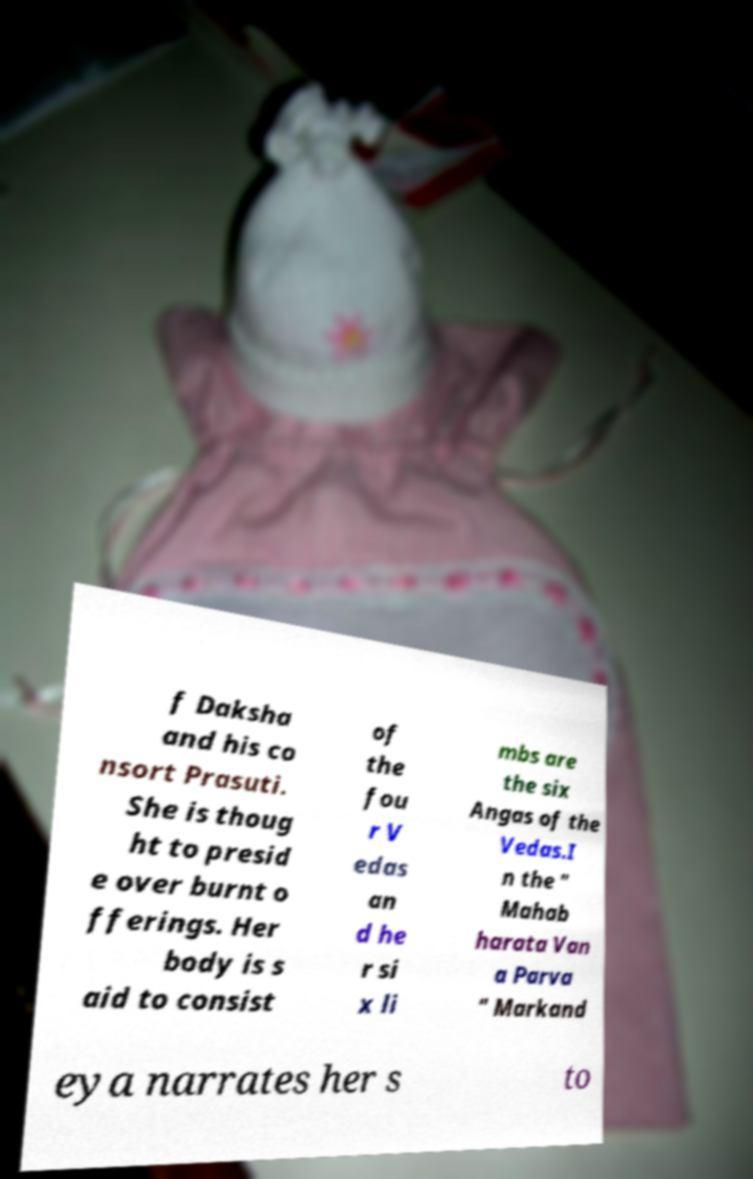What messages or text are displayed in this image? I need them in a readable, typed format. f Daksha and his co nsort Prasuti. She is thoug ht to presid e over burnt o fferings. Her body is s aid to consist of the fou r V edas an d he r si x li mbs are the six Angas of the Vedas.I n the " Mahab harata Van a Parva " Markand eya narrates her s to 